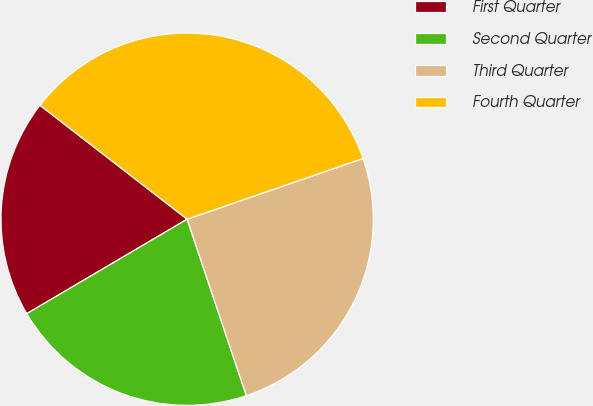Convert chart. <chart><loc_0><loc_0><loc_500><loc_500><pie_chart><fcel>First Quarter<fcel>Second Quarter<fcel>Third Quarter<fcel>Fourth Quarter<nl><fcel>18.96%<fcel>21.68%<fcel>25.14%<fcel>34.22%<nl></chart> 